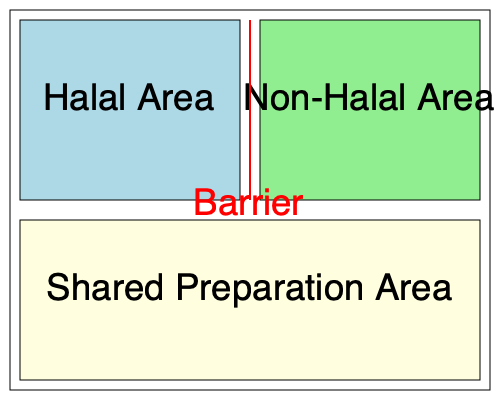In the kitchen layout shown above, which design element is crucial for preventing cross-contamination between halal and non-halal food preparation areas? To understand the importance of preventing cross-contamination in halal food preparation, we need to consider the following steps:

1. Halal food requirements: Halal food must not come into contact with non-halal items, particularly pork and alcohol, at any stage of preparation.

2. Kitchen layout analysis:
   a. The diagram shows a kitchen divided into three main areas:
      - Halal Area (light blue)
      - Non-Halal Area (light green)
      - Shared Preparation Area (light yellow)
   b. A red line separates the Halal and Non-Halal areas, labeled as a "Barrier"

3. Cross-contamination prevention:
   a. The physical barrier between Halal and Non-Halal areas is crucial for preventing accidental mixing of ingredients or utensils.
   b. This barrier ensures that food particles, liquids, or even airborne contaminants from the non-halal area do not reach the halal area.

4. Importance of the barrier:
   a. It creates a clear visual and physical separation between the two areas.
   b. It reminds kitchen staff to maintain strict separation protocols.
   c. It helps in maintaining the integrity of halal food preparation.

5. Additional considerations:
   a. The shared preparation area should have strict protocols for cleaning and sanitizing between halal and non-halal food preparation.
   b. Separate utensils, cutting boards, and equipment should be used in each area.

Therefore, the crucial design element for preventing cross-contamination between halal and non-halal food preparation areas is the physical barrier represented by the red line in the diagram.
Answer: The barrier (red line) between halal and non-halal areas 